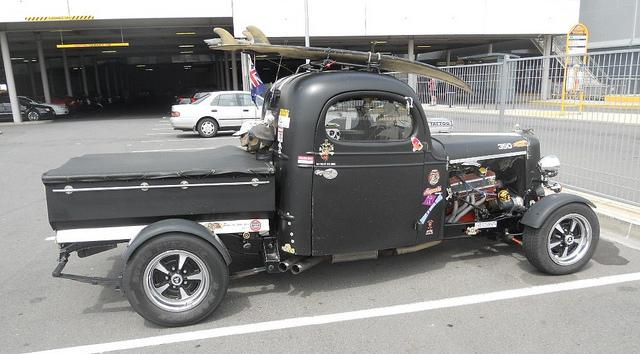What hobby does the car owner enjoy? Please explain your reasoning. surfing. There is a board for a water sport on the roof of the car. 